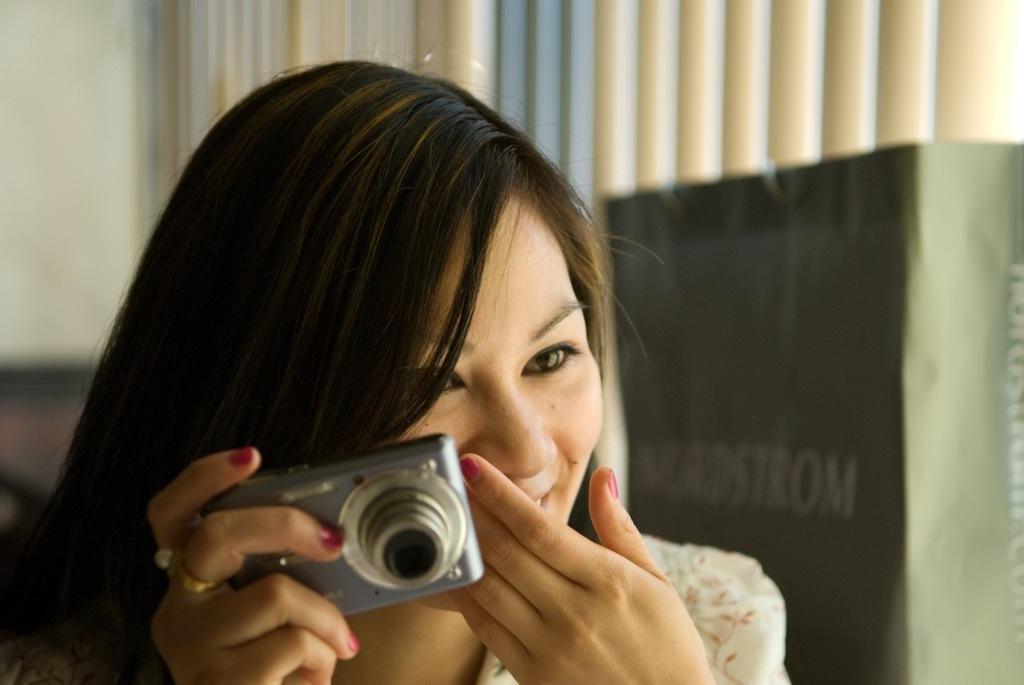Can you describe this image briefly? In this image we can see a woman holding a camera in her hand. In the background we can see a bag. 